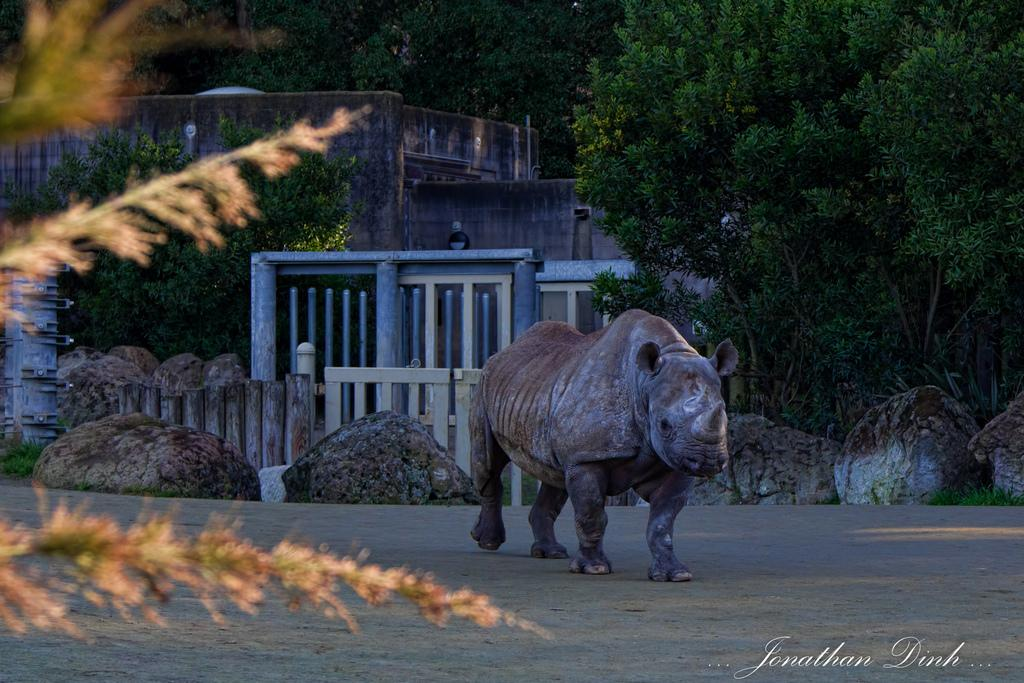What animal is on the road in the image? There is a one-horned rhinoceros on the road in the image. What can be seen in the background of the image? There are rocks, at least one building, trees, and railings in the background. How many buildings are visible in the background? The fact only mentions "at least one building," so we cannot determine the exact number. What type of food is being served in the lunchroom in the image? There is no lunchroom present in the image. What is the rhinoceros saying with its voice in the image? Rhinoceroses do not have the ability to speak or use a voice, so this question cannot be answered. 